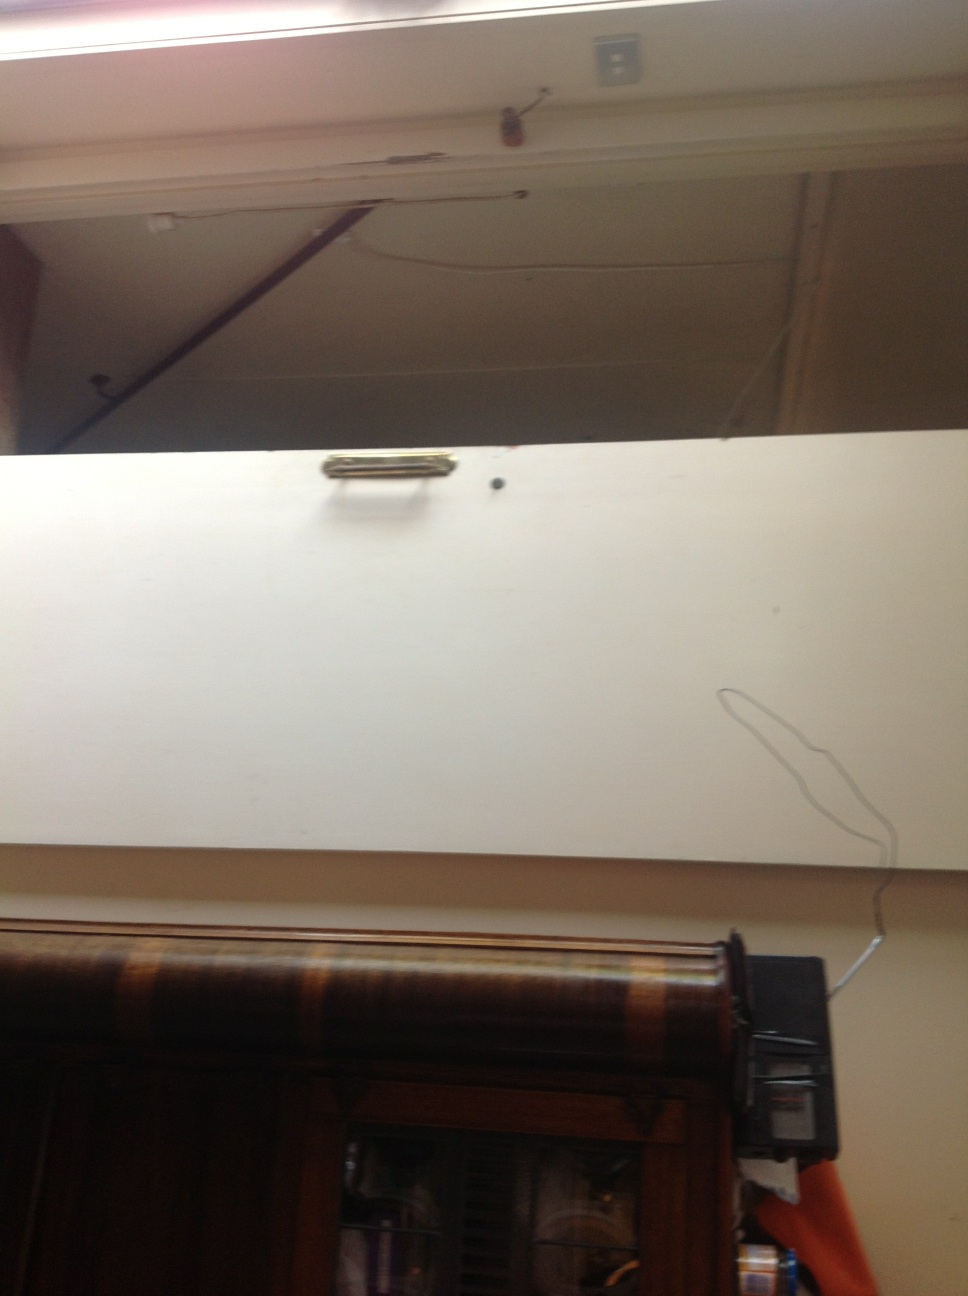What color is the door? The door is mostly white but features a prominent brown wooden frame at the bottom, complementing its simple design. 